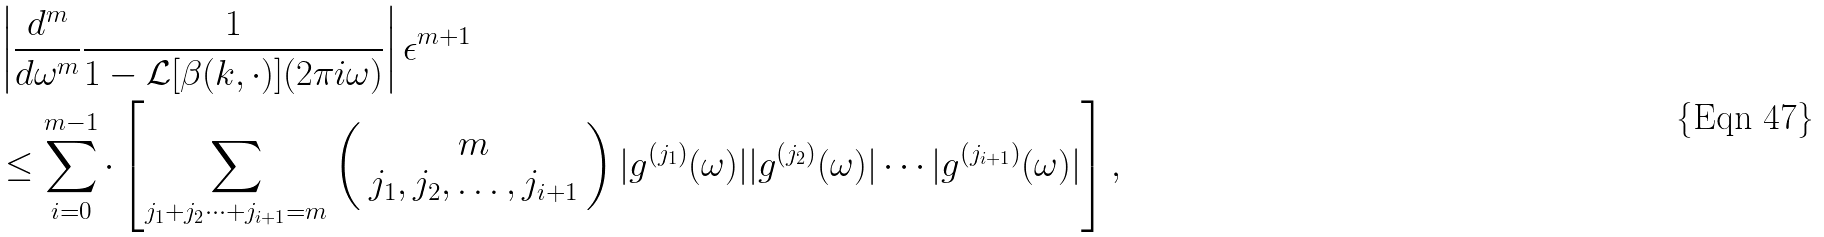Convert formula to latex. <formula><loc_0><loc_0><loc_500><loc_500>& \left | \frac { d ^ { m } } { d \omega ^ { m } } \frac { 1 } { 1 - \mathcal { L } [ \beta ( k , \cdot ) ] ( 2 \pi i \omega ) } \right | \epsilon ^ { m + 1 } \\ & \leq \sum _ { i = 0 } ^ { m - 1 } \cdot \left [ \sum _ { j _ { 1 } + j _ { 2 } \cdots + j _ { i + 1 } = m } \left ( \begin{array} { c } m \\ j _ { 1 } , j _ { 2 } , \dots , j _ { i + 1 } \end{array} \right ) | g ^ { ( j _ { 1 } ) } ( \omega ) | | g ^ { ( j _ { 2 } ) } ( \omega ) | \cdots | g ^ { ( j _ { i + 1 } ) } ( \omega ) | \right ] ,</formula> 